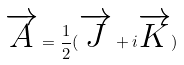<formula> <loc_0><loc_0><loc_500><loc_500>\overrightarrow { A } = \frac { 1 } { 2 } ( \overrightarrow { J } + i \overrightarrow { K } )</formula> 